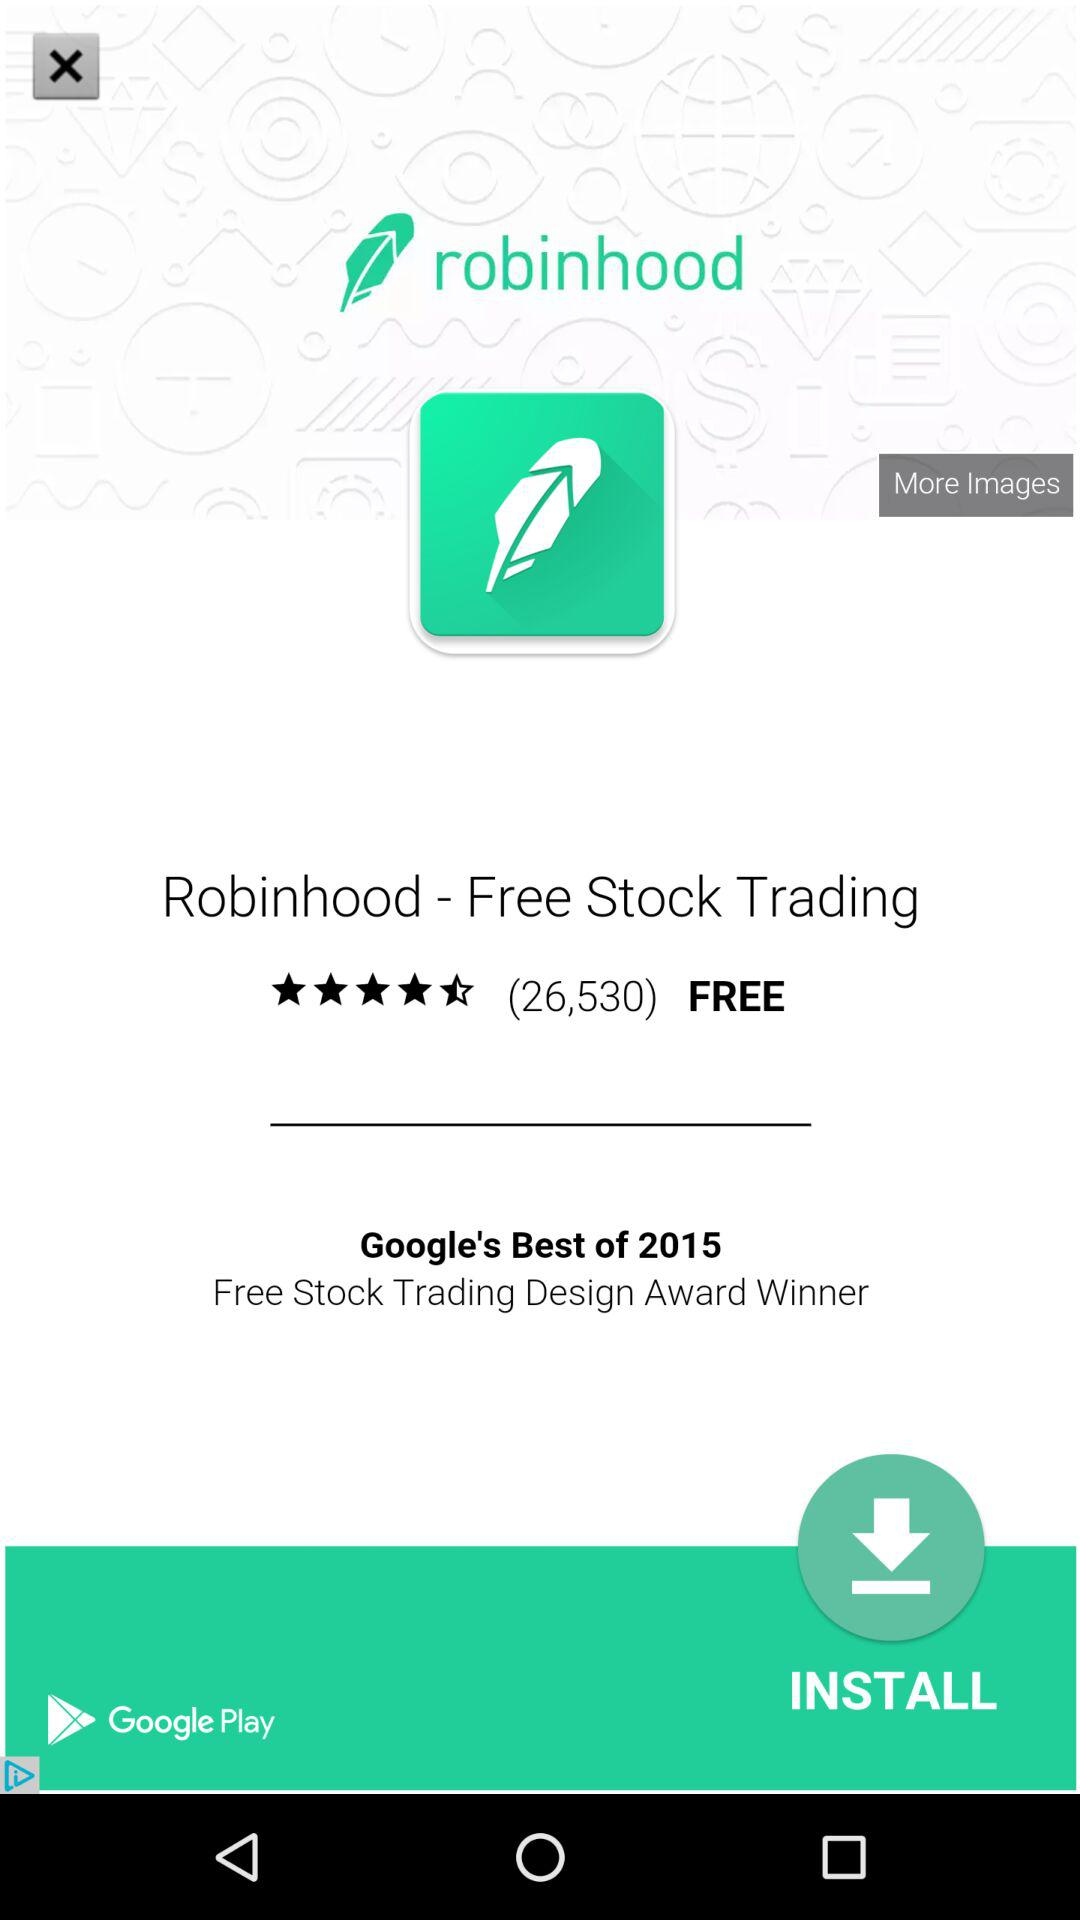What is the application name? The application name is "Robinhood - Free Stock Trading". 